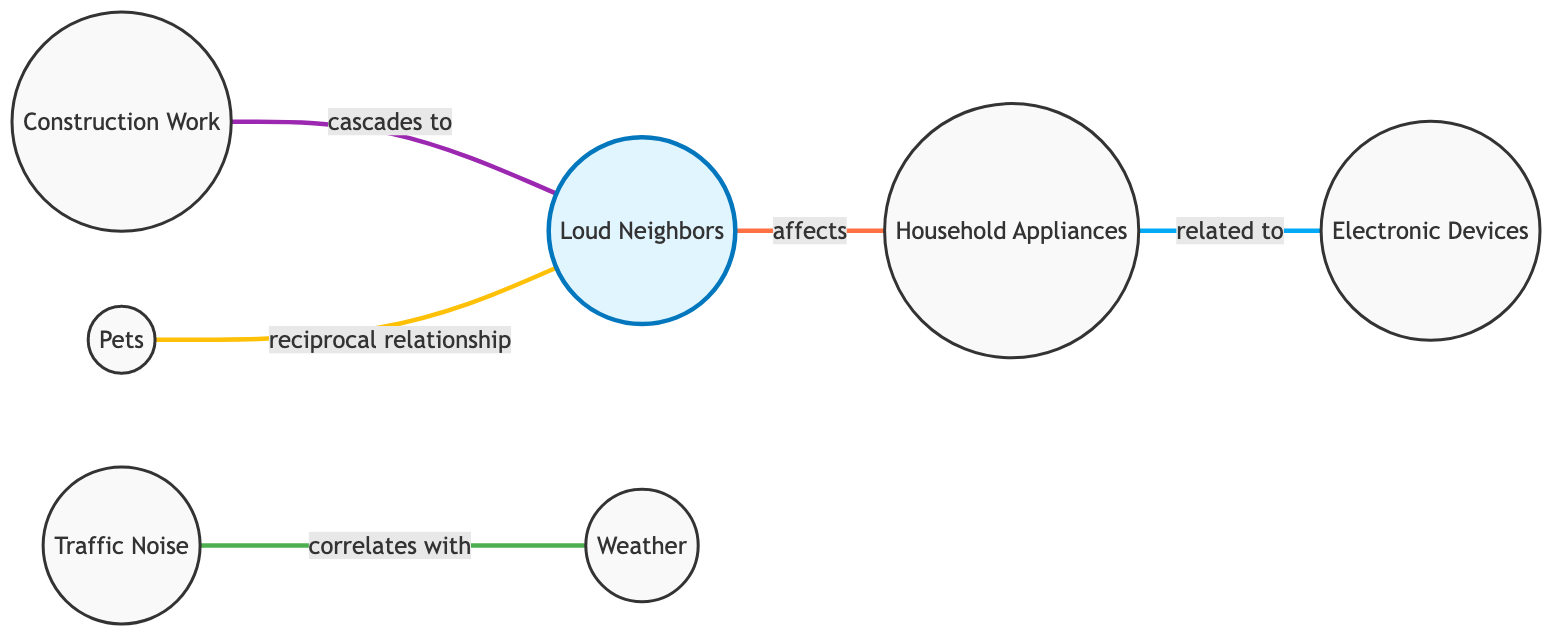What are the nodes in the diagram? The nodes in the diagram include Loud Neighbors, Traffic Noise, Construction Work, Household Appliances, Pets, Electronic Devices, and Weather.
Answer: Loud Neighbors, Traffic Noise, Construction Work, Household Appliances, Pets, Electronic Devices, Weather How many edges are there in the graph? The number of edges in the graph is counted based on the connections made between the nodes, which are five edges in total.
Answer: 5 What relationship exists between Loud Neighbors and Household Appliances? The relationship between Loud Neighbors and Household Appliances is described as "affects," indicating that the noise from neighbors may involve the use of household appliances.
Answer: affects Which noise source has a reciprocal relationship with Loud Neighbors? The noise source that has a reciprocal relationship with Loud Neighbors is Pets, suggesting that pets may react to noise from neighbors.
Answer: Pets How does Weather correlate with Traffic Noise? Weather correlates with Traffic Noise as the diagram indicates that traffic noise may be worse during adverse weather conditions, highlighting a connection between these two instances.
Answer: worse during adverse weather Which two nodes are directly connected to Construction Work? The nodes that are directly connected to Construction Work are Loud Neighbors and Pets, where one may lead to disturbances for the other.
Answer: Loud Neighbors, Pets If construction work occurs, which source is likely to experience increased noise? When construction work occurs, it is likely that Loud Neighbors will experience increased noise as their activities may render them disturbed, leading to more noise.
Answer: Loud Neighbors What is the relationship type between Household Appliances and Electronic Devices? The relationship type between Household Appliances and Electronic Devices is "related to," meaning that some household appliances are also classified as electronic devices.
Answer: related to In this undirected graph, what can be inferred about the connection between Traffic Noise and Weather? The inference from the connection between Traffic Noise and Weather is that they are correlated; specifically, traffic noise is likely to increase under certain weather conditions.
Answer: correlated 